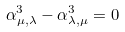<formula> <loc_0><loc_0><loc_500><loc_500>\alpha ^ { 3 } _ { \mu , \lambda } - \alpha ^ { 3 } _ { \lambda , \mu } = 0</formula> 